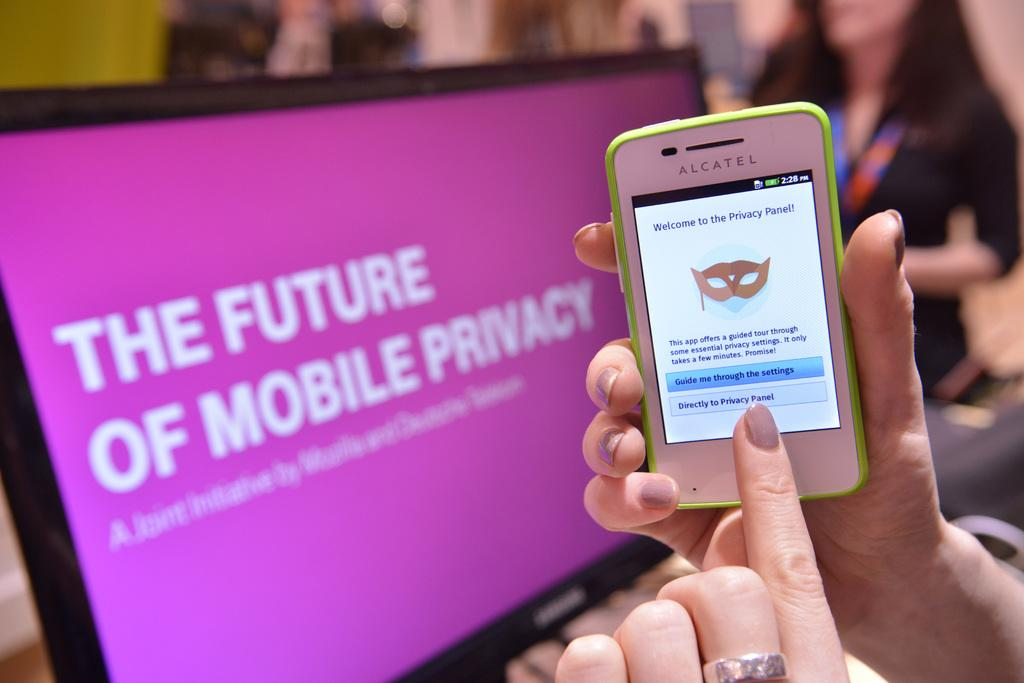What is the person holding in the image? The person is holding a mobile in the image. What can be seen in the background of the image? There is a monitor in the background of the image. What is displayed on the screen of the monitor? There is text visible on the screen of the monitor. How many people are present in the image? There are two people in the image. What type of book can be seen on the trees in the image? There are no books or trees present in the image. What kind of wood is used to build the monitor in the image? The monitor in the image is an electronic device and does not have wooden components. 